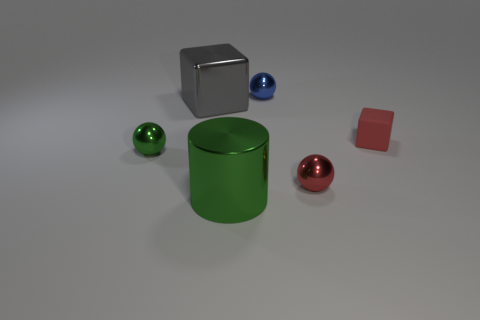Add 3 green spheres. How many objects exist? 9 Subtract all cylinders. How many objects are left? 5 Subtract all cyan shiny objects. Subtract all rubber things. How many objects are left? 5 Add 4 small red spheres. How many small red spheres are left? 5 Add 5 small red cubes. How many small red cubes exist? 6 Subtract 1 green spheres. How many objects are left? 5 